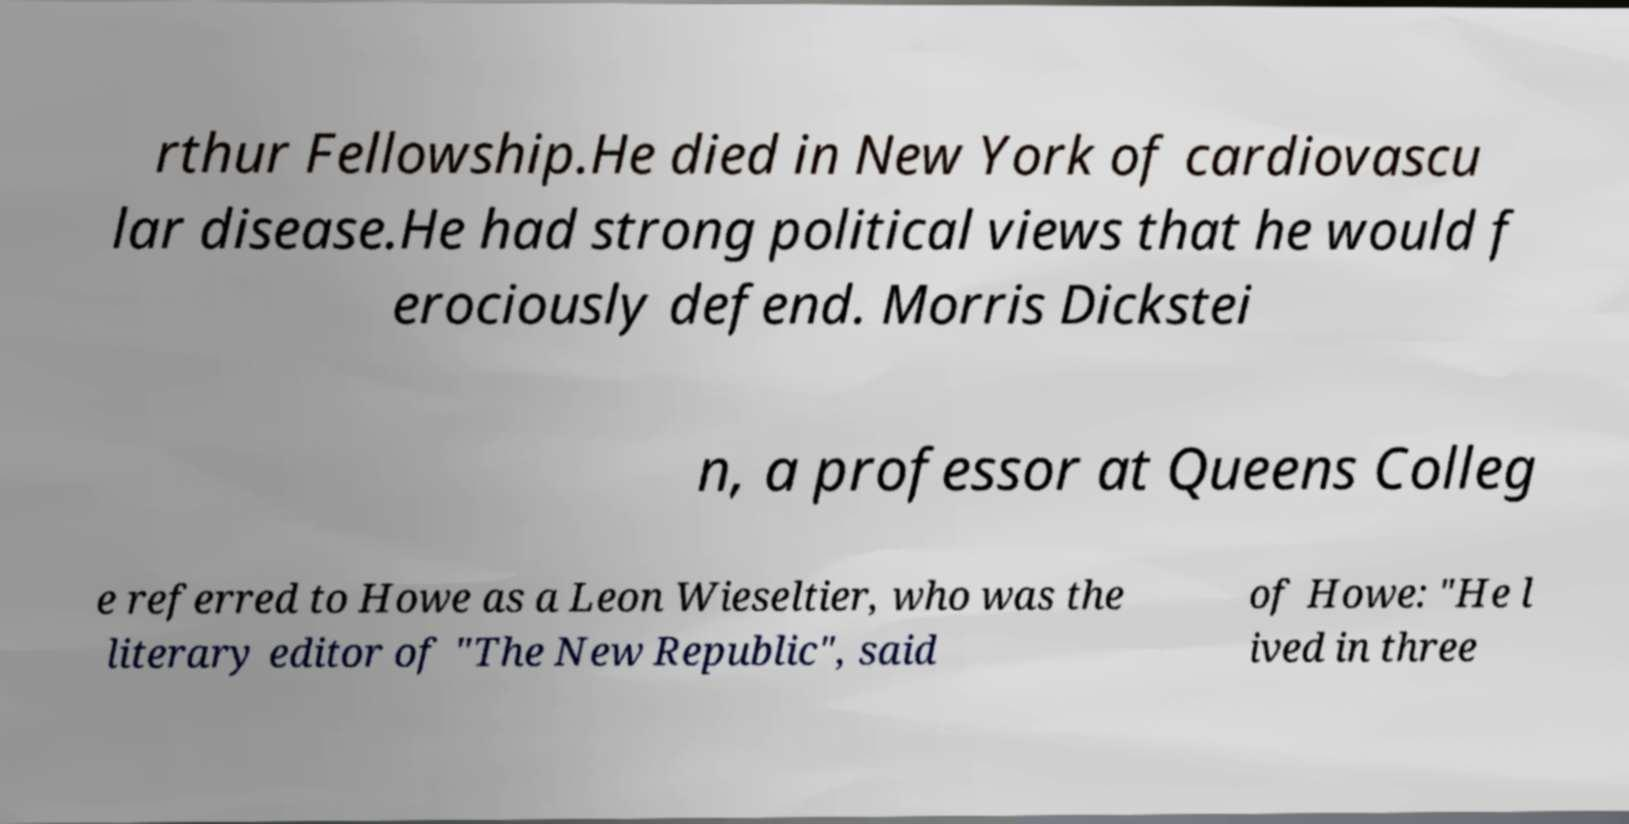What messages or text are displayed in this image? I need them in a readable, typed format. rthur Fellowship.He died in New York of cardiovascu lar disease.He had strong political views that he would f erociously defend. Morris Dickstei n, a professor at Queens Colleg e referred to Howe as a Leon Wieseltier, who was the literary editor of "The New Republic", said of Howe: "He l ived in three 